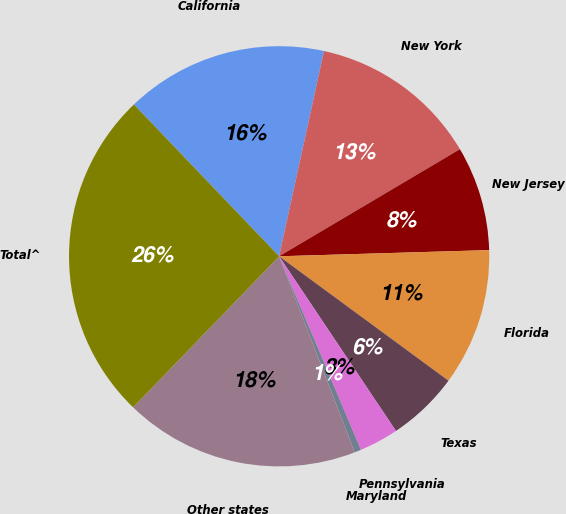<chart> <loc_0><loc_0><loc_500><loc_500><pie_chart><fcel>California<fcel>New York<fcel>New Jersey<fcel>Florida<fcel>Texas<fcel>Pennsylvania<fcel>Maryland<fcel>Other states<fcel>Total^<nl><fcel>15.57%<fcel>13.06%<fcel>8.04%<fcel>10.55%<fcel>5.53%<fcel>3.02%<fcel>0.51%<fcel>18.08%<fcel>25.61%<nl></chart> 